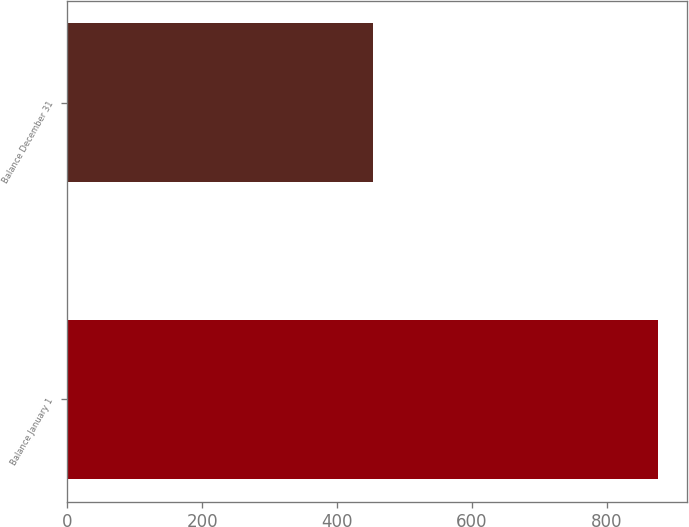<chart> <loc_0><loc_0><loc_500><loc_500><bar_chart><fcel>Balance January 1<fcel>Balance December 31<nl><fcel>876<fcel>454<nl></chart> 